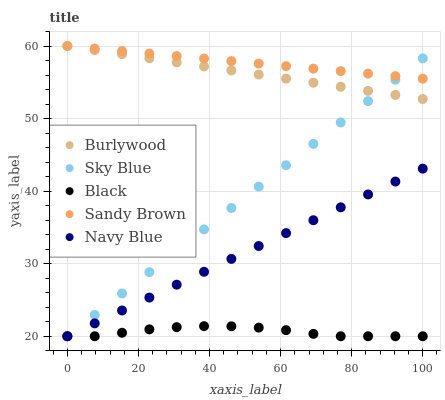Does Black have the minimum area under the curve?
Answer yes or no. Yes. Does Sandy Brown have the maximum area under the curve?
Answer yes or no. Yes. Does Sky Blue have the minimum area under the curve?
Answer yes or no. No. Does Sky Blue have the maximum area under the curve?
Answer yes or no. No. Is Sandy Brown the smoothest?
Answer yes or no. Yes. Is Black the roughest?
Answer yes or no. Yes. Is Sky Blue the smoothest?
Answer yes or no. No. Is Sky Blue the roughest?
Answer yes or no. No. Does Sky Blue have the lowest value?
Answer yes or no. Yes. Does Sandy Brown have the lowest value?
Answer yes or no. No. Does Sandy Brown have the highest value?
Answer yes or no. Yes. Does Sky Blue have the highest value?
Answer yes or no. No. Is Navy Blue less than Burlywood?
Answer yes or no. Yes. Is Burlywood greater than Black?
Answer yes or no. Yes. Does Navy Blue intersect Sky Blue?
Answer yes or no. Yes. Is Navy Blue less than Sky Blue?
Answer yes or no. No. Is Navy Blue greater than Sky Blue?
Answer yes or no. No. Does Navy Blue intersect Burlywood?
Answer yes or no. No. 